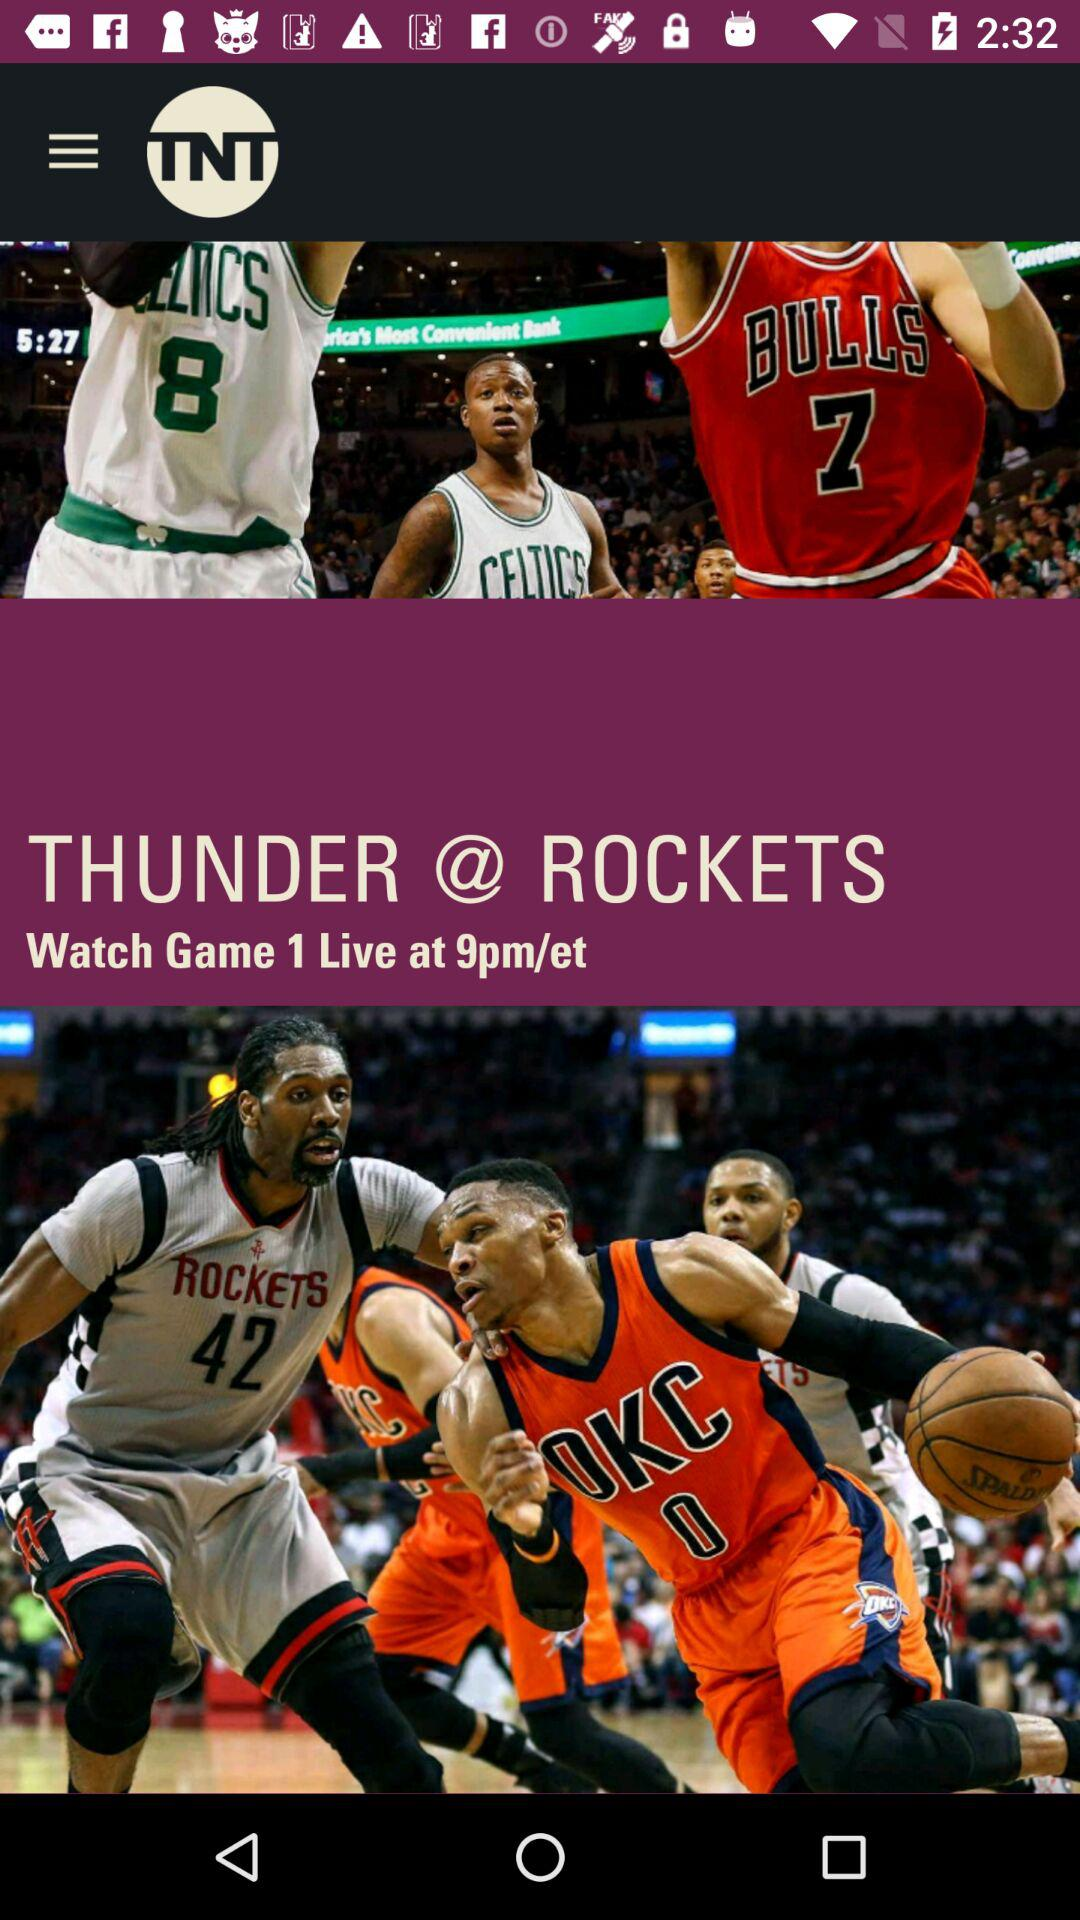The match is played between which teams? The match is played between "THUNDER" and "ROCKETS". 